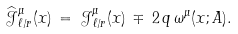<formula> <loc_0><loc_0><loc_500><loc_500>\widehat { \mathcal { J } } _ { \ell / r } ^ { \mu } ( x ) \, = \, { \mathcal { J } } _ { \ell / r } ^ { \mu } ( x ) \, \mp \, 2 \, q \, \omega ^ { \mu } ( x ; A ) .</formula> 